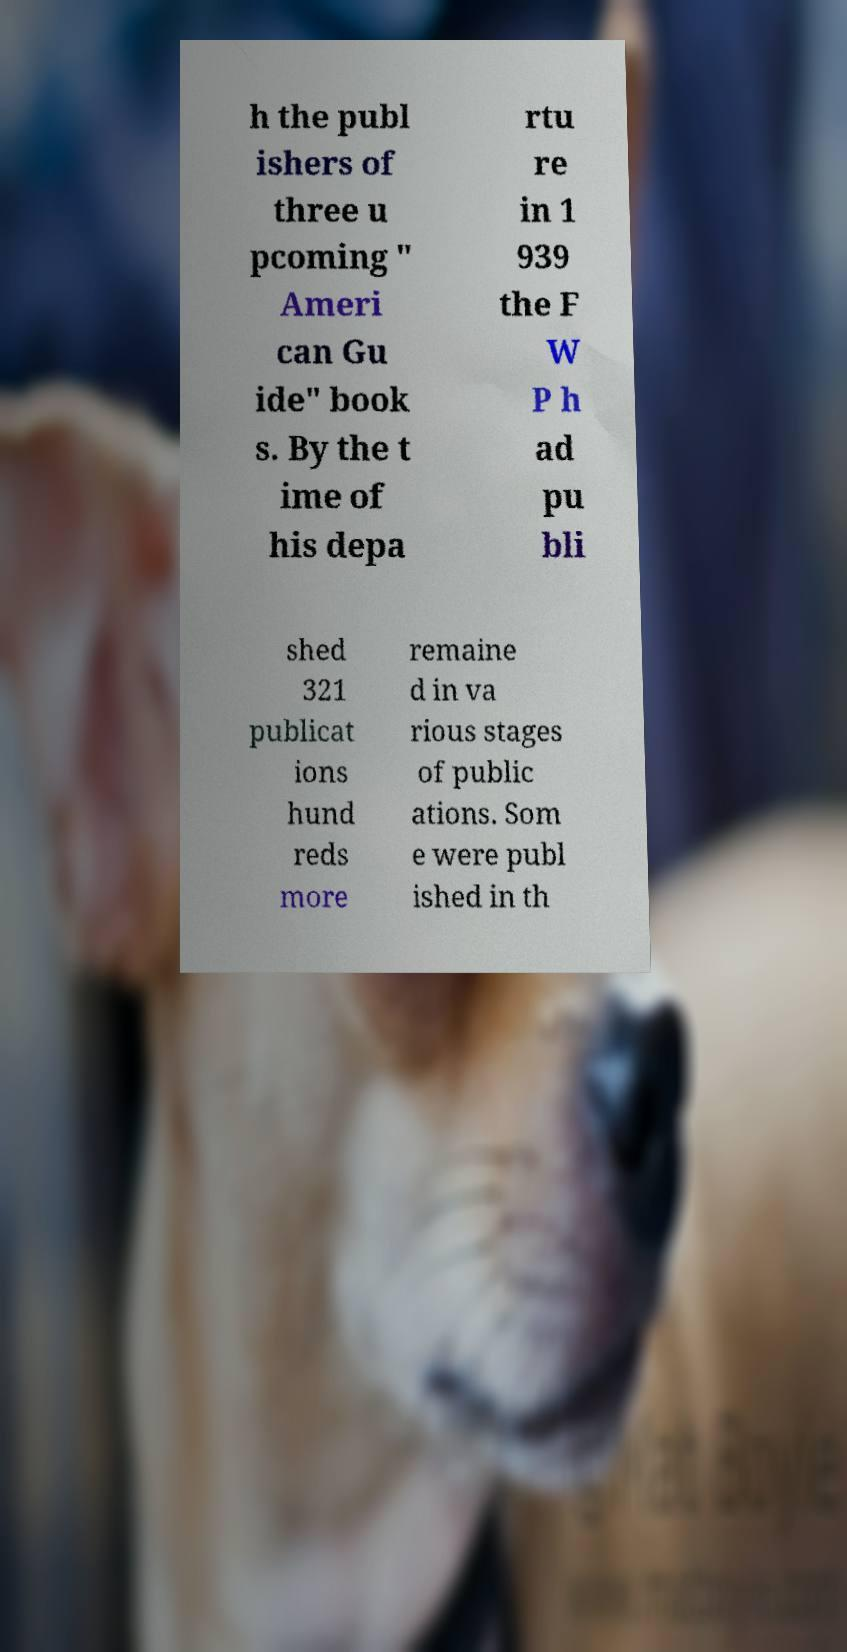Please read and relay the text visible in this image. What does it say? h the publ ishers of three u pcoming " Ameri can Gu ide" book s. By the t ime of his depa rtu re in 1 939 the F W P h ad pu bli shed 321 publicat ions hund reds more remaine d in va rious stages of public ations. Som e were publ ished in th 